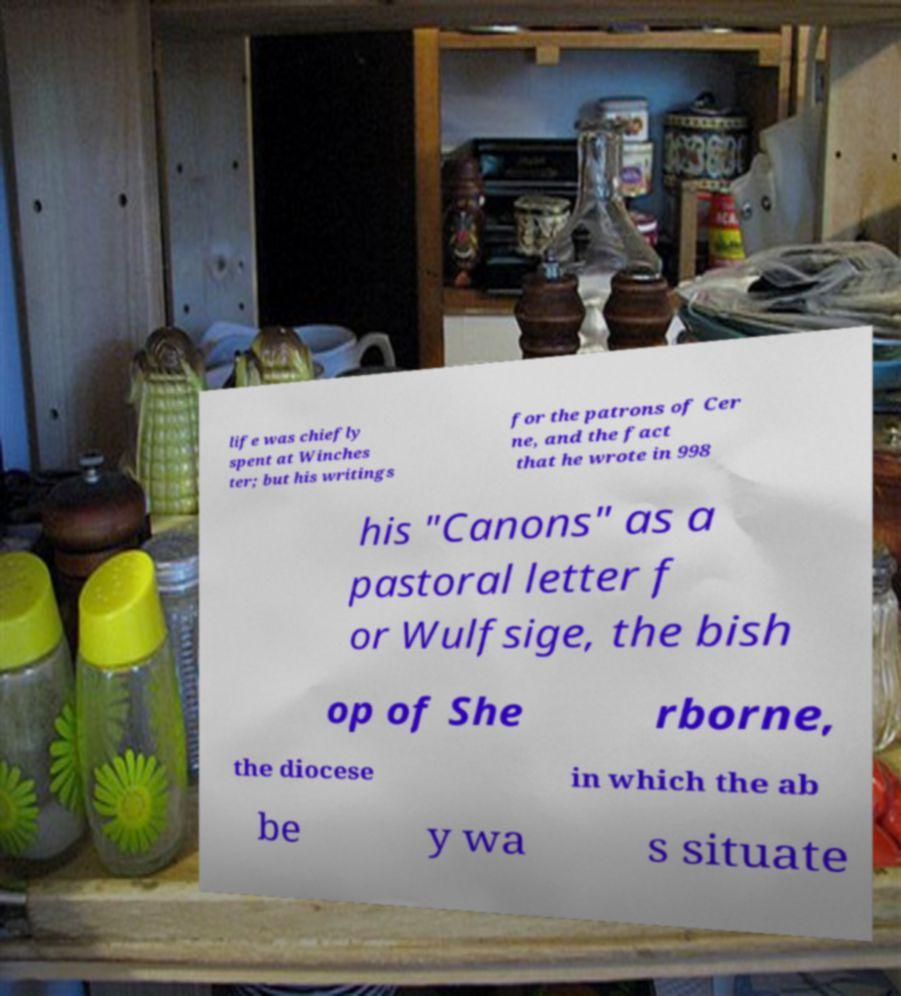Please read and relay the text visible in this image. What does it say? life was chiefly spent at Winches ter; but his writings for the patrons of Cer ne, and the fact that he wrote in 998 his "Canons" as a pastoral letter f or Wulfsige, the bish op of She rborne, the diocese in which the ab be y wa s situate 